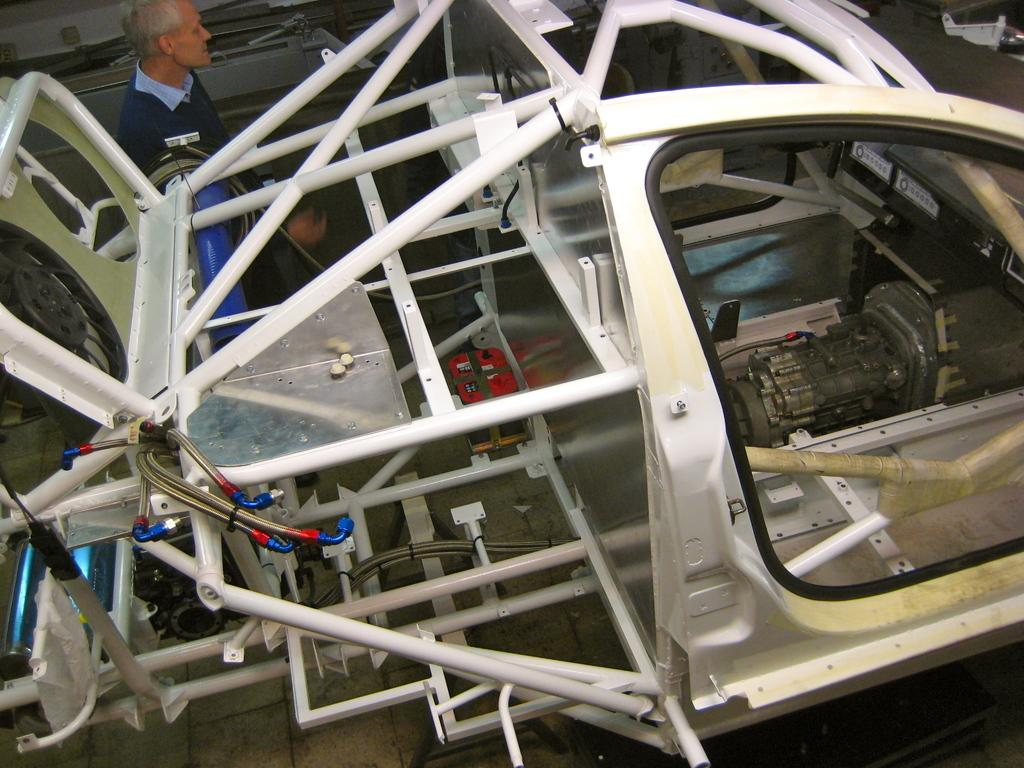What is located in the foreground of the image? There are parts of a vehicle in the foreground of the image. What can be seen in the background of the image? There is a person and metal objects in the background of the image. What is visible at the bottom of the image? The floor is visible at the bottom of the image. How does the person in the background express their disgust in the image? There is no indication of disgust in the image; the person's expression or actions are not described. 